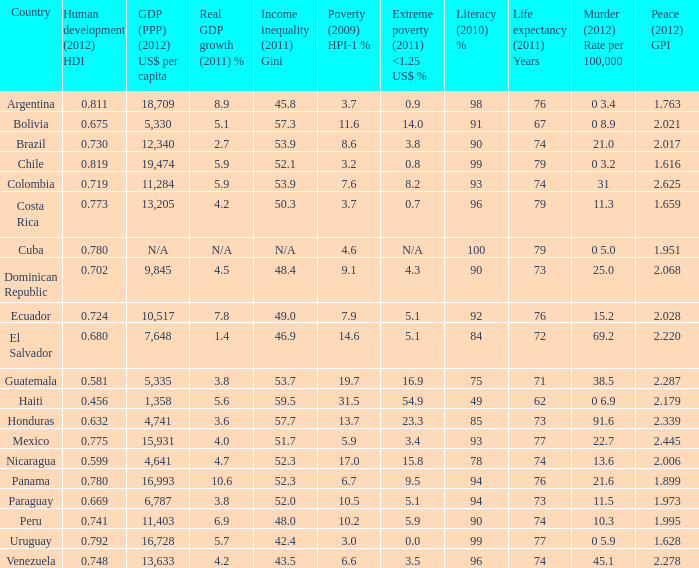What is the hpi-1 percentage for poverty in 2009 when the per capita gdp (ppp) in 2012 is 11,284 us dollars? 1.0. 